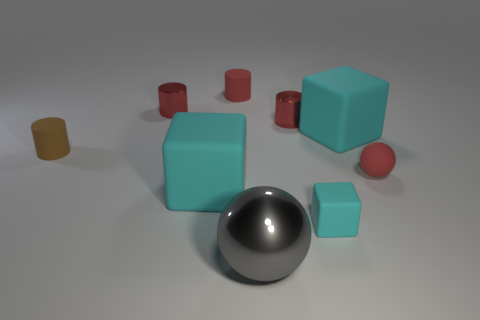How many cyan cubes must be subtracted to get 1 cyan cubes? 2 Subtract all cyan spheres. How many red cylinders are left? 3 Subtract all balls. How many objects are left? 7 Add 9 metal spheres. How many metal spheres exist? 10 Subtract 0 cyan cylinders. How many objects are left? 9 Subtract all big cyan matte spheres. Subtract all blocks. How many objects are left? 6 Add 3 big metal objects. How many big metal objects are left? 4 